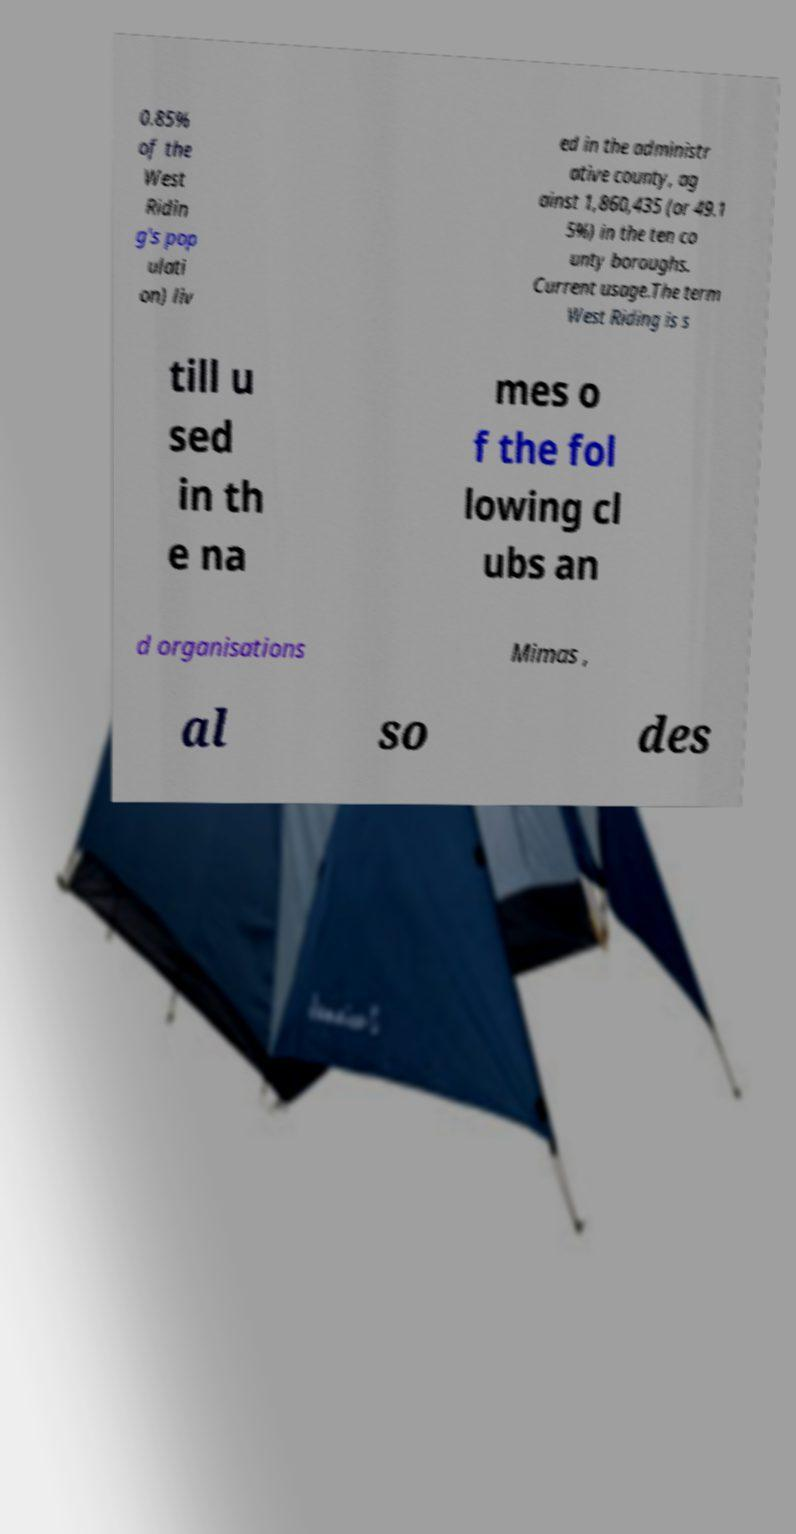Please read and relay the text visible in this image. What does it say? 0.85% of the West Ridin g's pop ulati on) liv ed in the administr ative county, ag ainst 1,860,435 (or 49.1 5%) in the ten co unty boroughs. Current usage.The term West Riding is s till u sed in th e na mes o f the fol lowing cl ubs an d organisations Mimas , al so des 